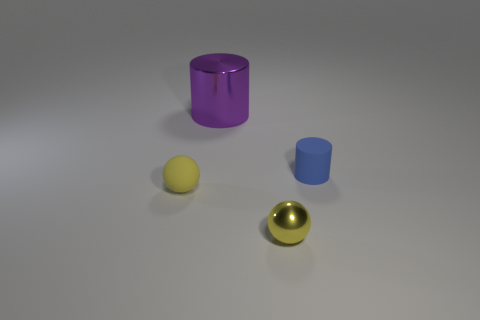Add 1 blue rubber blocks. How many objects exist? 5 Subtract 1 purple cylinders. How many objects are left? 3 Subtract all matte spheres. Subtract all purple objects. How many objects are left? 2 Add 3 big purple objects. How many big purple objects are left? 4 Add 2 small matte spheres. How many small matte spheres exist? 3 